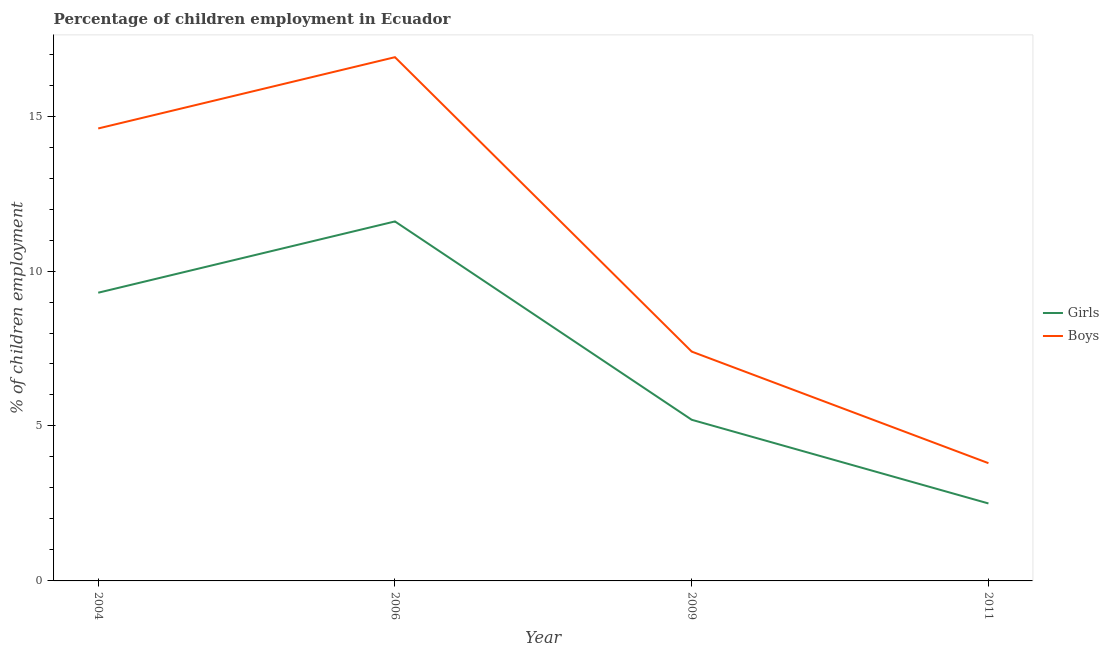How many different coloured lines are there?
Offer a terse response. 2. What is the percentage of employed girls in 2006?
Offer a very short reply. 11.6. Across all years, what is the maximum percentage of employed boys?
Offer a terse response. 16.9. In which year was the percentage of employed boys maximum?
Ensure brevity in your answer.  2006. What is the total percentage of employed girls in the graph?
Provide a succinct answer. 28.6. What is the difference between the percentage of employed girls in 2004 and that in 2006?
Your answer should be very brief. -2.3. What is the difference between the percentage of employed boys in 2011 and the percentage of employed girls in 2004?
Ensure brevity in your answer.  -5.5. What is the average percentage of employed girls per year?
Give a very brief answer. 7.15. In the year 2011, what is the difference between the percentage of employed girls and percentage of employed boys?
Keep it short and to the point. -1.3. In how many years, is the percentage of employed boys greater than 16 %?
Your answer should be very brief. 1. What is the ratio of the percentage of employed boys in 2004 to that in 2011?
Offer a very short reply. 3.84. Is the percentage of employed boys in 2004 less than that in 2009?
Ensure brevity in your answer.  No. What is the difference between the highest and the second highest percentage of employed boys?
Provide a succinct answer. 2.3. What is the difference between the highest and the lowest percentage of employed girls?
Keep it short and to the point. 9.1. In how many years, is the percentage of employed boys greater than the average percentage of employed boys taken over all years?
Make the answer very short. 2. Does the percentage of employed boys monotonically increase over the years?
Offer a terse response. No. Are the values on the major ticks of Y-axis written in scientific E-notation?
Ensure brevity in your answer.  No. Does the graph contain any zero values?
Provide a succinct answer. No. What is the title of the graph?
Give a very brief answer. Percentage of children employment in Ecuador. Does "Short-term debt" appear as one of the legend labels in the graph?
Provide a succinct answer. No. What is the label or title of the X-axis?
Your answer should be compact. Year. What is the label or title of the Y-axis?
Offer a very short reply. % of children employment. What is the % of children employment of Girls in 2004?
Offer a very short reply. 9.3. What is the % of children employment in Boys in 2004?
Your answer should be very brief. 14.6. What is the % of children employment in Girls in 2006?
Make the answer very short. 11.6. What is the % of children employment of Boys in 2006?
Give a very brief answer. 16.9. What is the % of children employment of Girls in 2009?
Provide a short and direct response. 5.2. What is the % of children employment in Boys in 2009?
Provide a succinct answer. 7.4. What is the % of children employment of Girls in 2011?
Provide a short and direct response. 2.5. What is the % of children employment of Boys in 2011?
Ensure brevity in your answer.  3.8. Across all years, what is the maximum % of children employment in Boys?
Provide a short and direct response. 16.9. Across all years, what is the minimum % of children employment of Girls?
Give a very brief answer. 2.5. Across all years, what is the minimum % of children employment in Boys?
Make the answer very short. 3.8. What is the total % of children employment in Girls in the graph?
Your response must be concise. 28.6. What is the total % of children employment in Boys in the graph?
Provide a succinct answer. 42.7. What is the difference between the % of children employment of Girls in 2004 and that in 2009?
Your answer should be very brief. 4.1. What is the difference between the % of children employment of Girls in 2009 and that in 2011?
Ensure brevity in your answer.  2.7. What is the difference between the % of children employment of Girls in 2004 and the % of children employment of Boys in 2006?
Offer a very short reply. -7.6. What is the difference between the % of children employment in Girls in 2004 and the % of children employment in Boys in 2009?
Offer a very short reply. 1.9. What is the difference between the % of children employment in Girls in 2004 and the % of children employment in Boys in 2011?
Keep it short and to the point. 5.5. What is the average % of children employment in Girls per year?
Your answer should be compact. 7.15. What is the average % of children employment in Boys per year?
Provide a short and direct response. 10.68. In the year 2006, what is the difference between the % of children employment in Girls and % of children employment in Boys?
Ensure brevity in your answer.  -5.3. In the year 2009, what is the difference between the % of children employment in Girls and % of children employment in Boys?
Keep it short and to the point. -2.2. In the year 2011, what is the difference between the % of children employment in Girls and % of children employment in Boys?
Keep it short and to the point. -1.3. What is the ratio of the % of children employment in Girls in 2004 to that in 2006?
Make the answer very short. 0.8. What is the ratio of the % of children employment of Boys in 2004 to that in 2006?
Give a very brief answer. 0.86. What is the ratio of the % of children employment in Girls in 2004 to that in 2009?
Give a very brief answer. 1.79. What is the ratio of the % of children employment of Boys in 2004 to that in 2009?
Provide a succinct answer. 1.97. What is the ratio of the % of children employment in Girls in 2004 to that in 2011?
Ensure brevity in your answer.  3.72. What is the ratio of the % of children employment of Boys in 2004 to that in 2011?
Your response must be concise. 3.84. What is the ratio of the % of children employment of Girls in 2006 to that in 2009?
Offer a terse response. 2.23. What is the ratio of the % of children employment of Boys in 2006 to that in 2009?
Your answer should be very brief. 2.28. What is the ratio of the % of children employment of Girls in 2006 to that in 2011?
Offer a terse response. 4.64. What is the ratio of the % of children employment of Boys in 2006 to that in 2011?
Give a very brief answer. 4.45. What is the ratio of the % of children employment in Girls in 2009 to that in 2011?
Offer a very short reply. 2.08. What is the ratio of the % of children employment in Boys in 2009 to that in 2011?
Offer a very short reply. 1.95. What is the difference between the highest and the second highest % of children employment in Girls?
Make the answer very short. 2.3. What is the difference between the highest and the second highest % of children employment in Boys?
Provide a short and direct response. 2.3. What is the difference between the highest and the lowest % of children employment of Boys?
Ensure brevity in your answer.  13.1. 